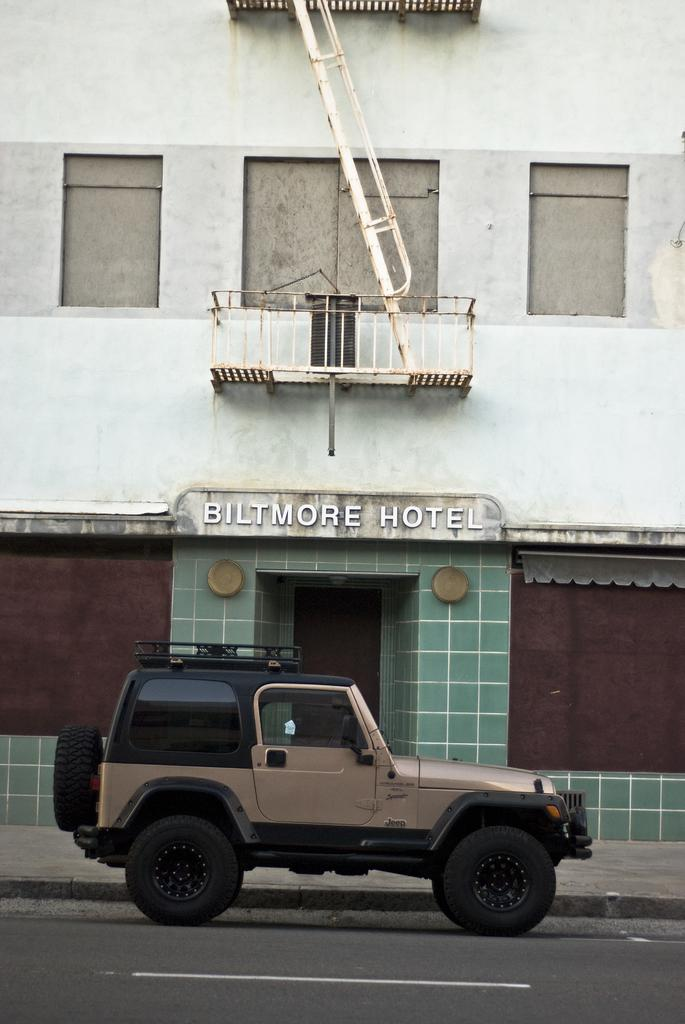What is the main subject of the image? There is a vehicle on the road in the image. What can be seen in the background of the image? There is a building and a railing in the background of the image. What type of chalk is being used to draw on the vehicle in the image? There is no chalk or drawing on the vehicle in the image. Can you hear the people laughing in the image? There is no audio or indication of laughter in the image. 